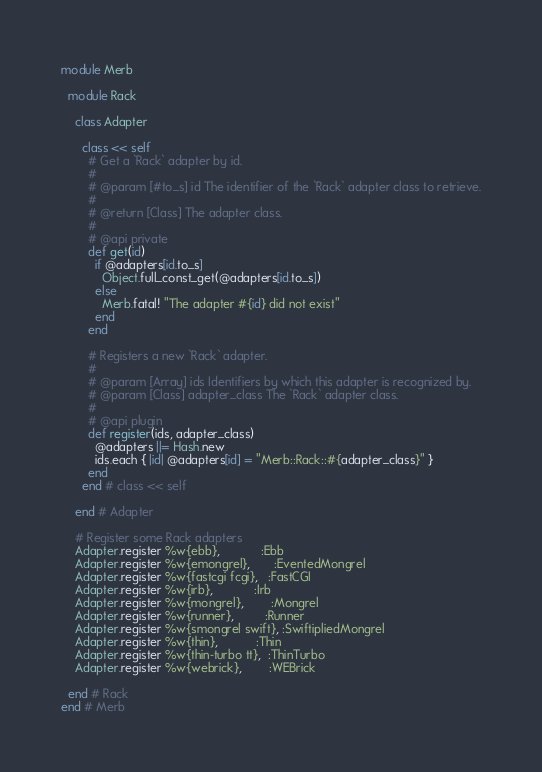Convert code to text. <code><loc_0><loc_0><loc_500><loc_500><_Ruby_>module Merb

  module Rack

    class Adapter

      class << self
        # Get a `Rack` adapter by id.
        #
        # @param [#to_s] id The identifier of the `Rack` adapter class to retrieve.
        #
        # @return [Class] The adapter class.
        #
        # @api private
        def get(id)
          if @adapters[id.to_s]
            Object.full_const_get(@adapters[id.to_s])
          else
            Merb.fatal! "The adapter #{id} did not exist"
          end
        end

        # Registers a new `Rack` adapter.
        #
        # @param [Array] ids Identifiers by which this adapter is recognized by.
        # @param [Class] adapter_class The `Rack` adapter class.
        #
        # @api plugin
        def register(ids, adapter_class)
          @adapters ||= Hash.new
          ids.each { |id| @adapters[id] = "Merb::Rack::#{adapter_class}" }
        end
      end # class << self

    end # Adapter

    # Register some Rack adapters
    Adapter.register %w{ebb},            :Ebb
    Adapter.register %w{emongrel},       :EventedMongrel
    Adapter.register %w{fastcgi fcgi},   :FastCGI
    Adapter.register %w{irb},            :Irb
    Adapter.register %w{mongrel},        :Mongrel
    Adapter.register %w{runner},         :Runner
    Adapter.register %w{smongrel swift}, :SwiftipliedMongrel
    Adapter.register %w{thin},           :Thin
    Adapter.register %w{thin-turbo tt},  :ThinTurbo
    Adapter.register %w{webrick},        :WEBrick

  end # Rack
end # Merb
</code> 